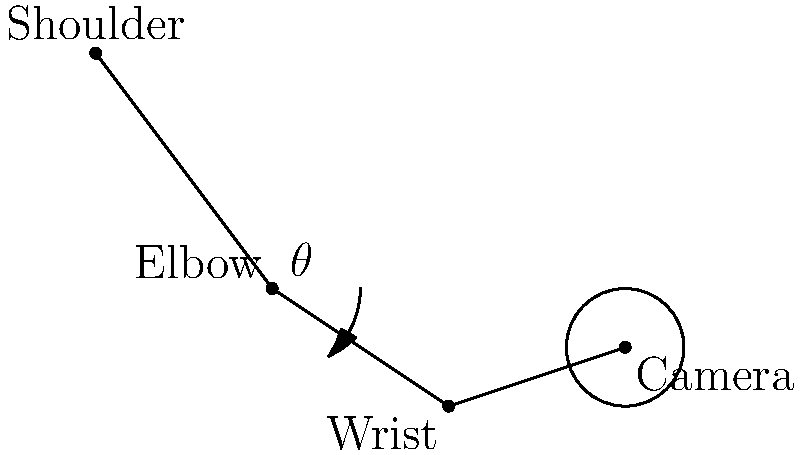While capturing Villapuram's sights, you hold your camera as shown in the diagram. The angle $\theta$ represents the elbow flexion. What is the optimal range for $\theta$ to minimize fatigue during extended periods of photography? To determine the optimal range for elbow flexion ($\theta$) during extended camera use, we need to consider the principles of ergonomics:

1. Neutral joint positions: Joints should be kept in neutral positions to reduce strain.
2. Minimizing static load: Prolonged static postures can lead to fatigue.
3. Comfort and efficiency: The position should allow for comfortable and efficient camera operation.

Given these principles:

1. A fully extended arm ($\theta = 0°$) would create excessive static load and fatigue.
2. A severely flexed elbow ($\theta > 90°$) would be uncomfortable and inefficient for camera operation.
3. Research in ergonomics suggests that the optimal elbow flexion for most tasks is between 90° and 120°.
4. However, for camera use, a slightly more extended position may be beneficial to stabilize the camera.

Therefore, the optimal range for $\theta$ would be approximately 70° to 110°. This range allows for:
- Reduced static load compared to a fully extended arm
- Sufficient stability for camera operation
- Comfortable positioning for extended use
- Flexibility to adjust based on the specific shot and individual preference
Answer: 70° to 110° 